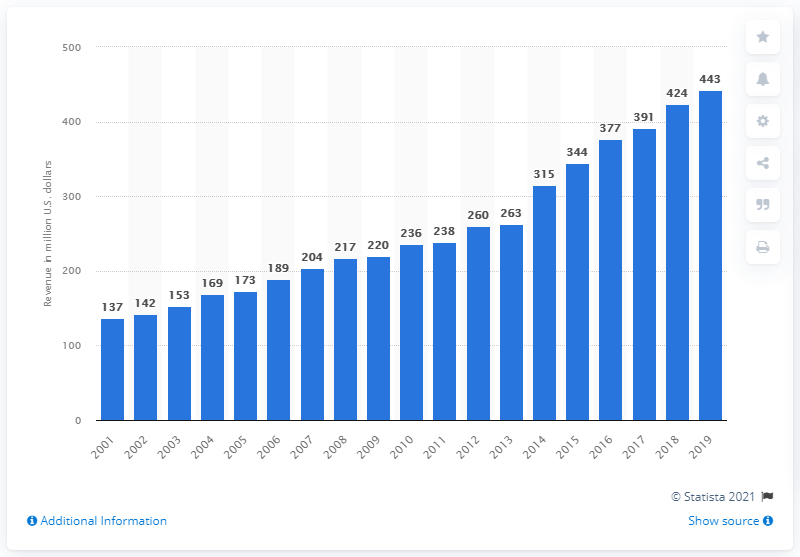List a handful of essential elements in this visual. The revenue of the Jacksonville Jaguars in 2019 was approximately 443 million dollars. The Jacksonville Jaguars first made money in 2001. 